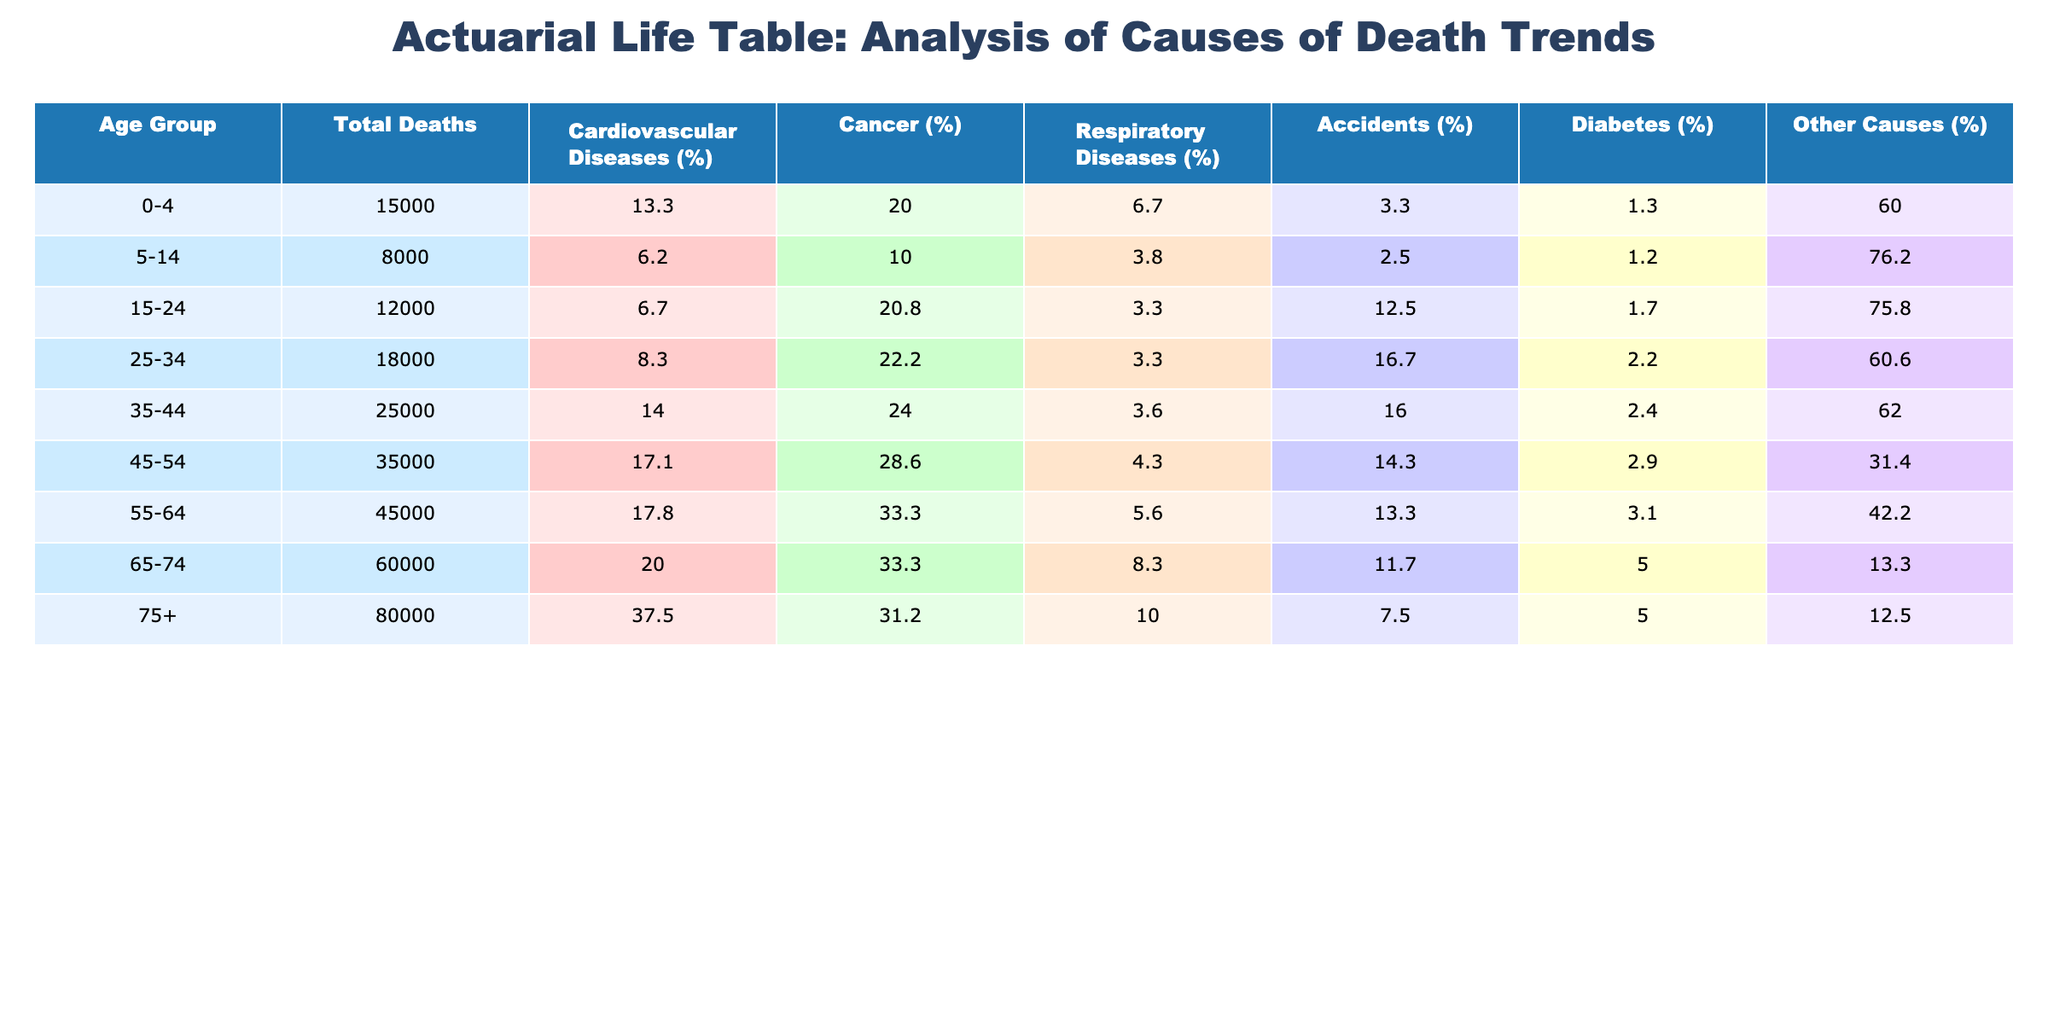What is the total number of deaths in the age group 45-54? According to the table, the total number of deaths in the age group 45-54 is listed as 35,000.
Answer: 35,000 Which cause of death accounts for the highest percentage in the age group 75+? In the age group 75+, the highest percentage of deaths is from cardiovascular diseases, which accounts for 37.5% of total deaths.
Answer: 37.5% What are the total deaths from accidents across all age groups? By summing the deaths from accidents for each age group: 500 + 200 + 400 + 3000 + 4000 + 5000 + 7000 + 6000 = 20,100.
Answer: 20,100 Is cancer a leading cause of death in the age group 55-64 compared to cardiovascular diseases? Yes, cancer (33.3%) is indeed less than cardiovascular diseases (17.8%) in terms of percentage, indicating that cardiovascular diseases are more common in that age group.
Answer: Yes What is the percentage of deaths from diabetes in the age group 0-4? In the age group 0-4, deaths from diabetes account for 1.3% of total deaths, calculated by (200/15000)*100.
Answer: 1.3% How many total deaths were caused by respiratory diseases in the age group 25-34 and 35-44 combined? Adding the respiratory disease deaths in both age groups gives: 600 + 900 = 1500 total deaths.
Answer: 1500 What is the median percentage of total deaths caused by other causes across all age groups? The percentages for other causes in each age group are: 60.0%, 76.3%, 16.7%, 60.6%, 44.6%, 31.1%, 13.3%, 12.5%. Sorting gives: 12.5%, 13.3%, 16.7%, 31.1%, 44.6%, 60.0%, 60.6%, 76.3%. The median of these eight values (5th and 6th) is (44.6% + 60.0%)/2 = 52.3%.
Answer: 52.3% In which age group do we see the lowest percentage of deaths caused by diabetes? The age group 5-14 has the lowest percentage of diabetes deaths, which is 1.3% of total deaths in that age group.
Answer: 5-14 What is the difference in total deaths between the age groups 65-74 and 75+? The total deaths in the age group 65-74 is 60,000 and in the age group 75+ is 80,000. The difference thus is 80,000 - 60,000 = 20,000.
Answer: 20,000 